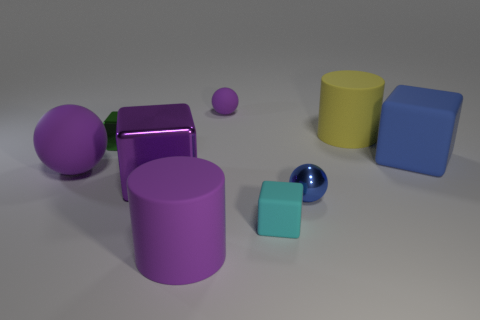Can you describe the texture of the objects in the scene? Certainly! The objects in the image have a smooth texture with a matte finish, except for the large purple sphere and the smaller dark blue sphere which have a reflective, shiny surface indicating a glossy texture. 